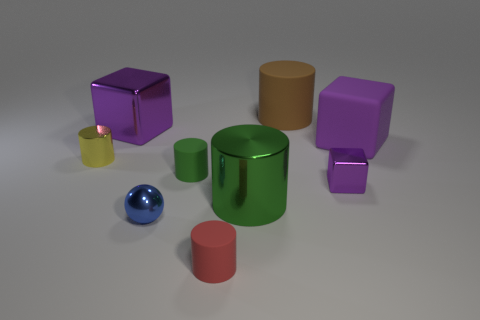Subtract all tiny green matte cylinders. How many cylinders are left? 4 Subtract all brown cylinders. How many cylinders are left? 4 Subtract all blue cylinders. Subtract all gray spheres. How many cylinders are left? 5 Add 1 matte objects. How many objects exist? 10 Subtract all large purple matte objects. Subtract all large metal cylinders. How many objects are left? 7 Add 4 green things. How many green things are left? 6 Add 3 metallic cylinders. How many metallic cylinders exist? 5 Subtract 0 cyan spheres. How many objects are left? 9 Subtract all cylinders. How many objects are left? 4 